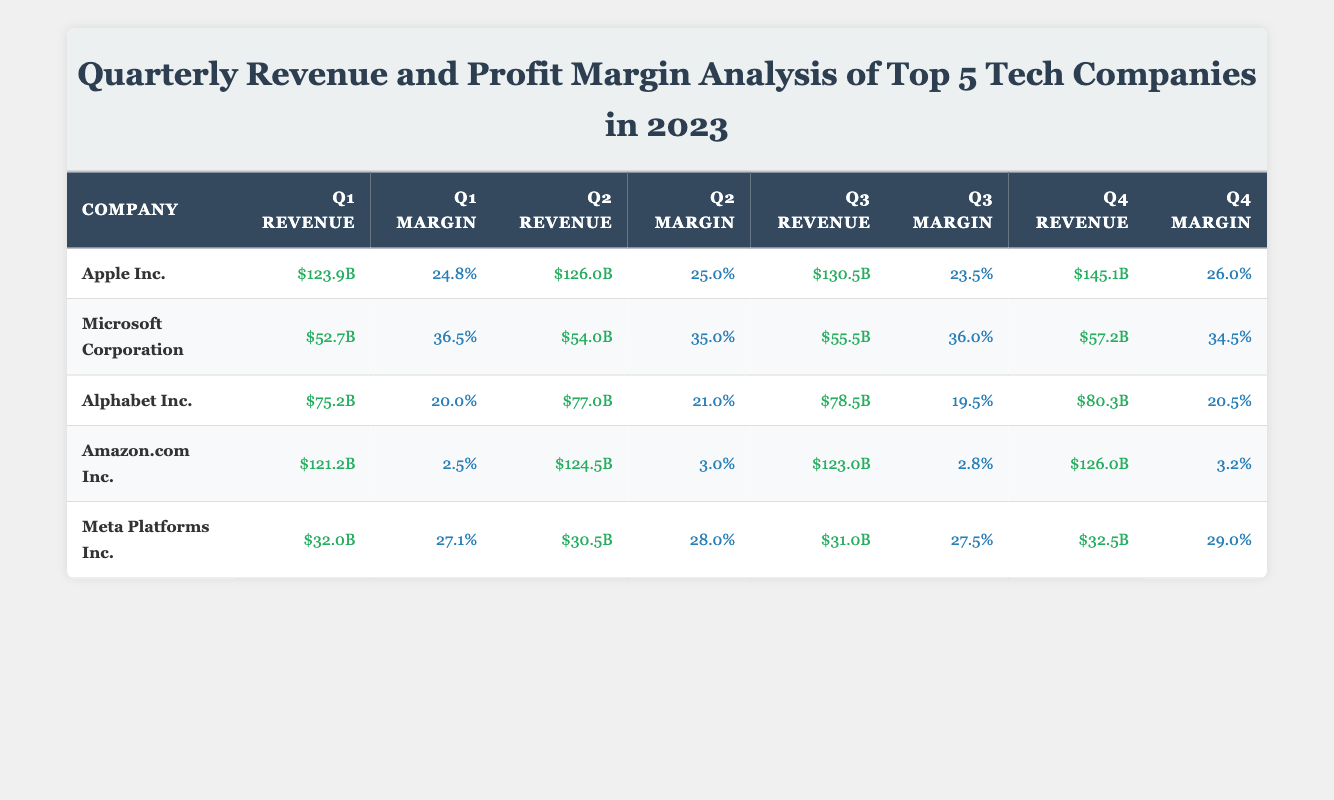What was Apple's revenue in Q2 2023? According to the table, Apple's revenue in Q2 is stated directly under the "Q2 Revenue" column for Apple Inc., which is $126.0 billion.
Answer: $126.0B Which company had the highest profit margin in Q1 2023? By looking at the "Q1 Margin" column, Microsoft Corporation displays the highest profit margin at 36.5%, as it is the largest value in that column compared to the other companies.
Answer: Microsoft Corporation What is the total revenue for Meta Platforms Inc. over all quarters? To find the total revenue, sum the revenues for Meta Platforms Inc. across the four quarters: ($32.0B + $30.5B + $31.0B + $32.5B) = $126.0B. Therefore, the total revenue is derived from adding all these figures together.
Answer: $126.0B Did Amazon.com Inc. see an increase in profit margin from Q1 to Q4? The profit margins for Amazon.com Inc. in Q1 is 2.5% and in Q4 is 3.2%. Since 3.2% is greater than 2.5%, Amazon did experience an increase in profit margin over this period.
Answer: Yes What is the average profit margin for Alphabet Inc. across the four quarters? The profit margins for Alphabet Inc. are 20.0%, 21.0%, 19.5%, and 20.5%. To find the average, add these margins (20.0 + 21.0 + 19.5 + 20.5 = 81.0) and divide by the number of quarters (4): 81.0 / 4 = 20.25%.
Answer: 20.25% What company maintained a profit margin of above 25% in every quarter? By examining the profit margin for each company across all quarters, Apple Inc. is the only company that had a profit margin above 25% in every quarter (24.8%, 25.0%, 23.5%, and 26.0%).
Answer: No Which company had the lowest revenue total across Q3? In Q3, examining the revenue figures: Apple Inc. ($130.5B), Microsoft Corporation ($55.5B), Alphabet Inc. ($78.5B), Amazon.com Inc. ($123.0B), and Meta Platforms Inc. ($31.0B), Meta Platforms Inc. has the lowest revenue at $31.0B.
Answer: Meta Platforms Inc What was the increase in revenue for Apple Inc. from Q1 to Q4? Apple's revenue in Q1 was $123.9B and in Q4 it was $145.1B. To calculate the increase, subtract Q1 revenue from Q4 revenue: $145.1B - $123.9B = $21.2B.
Answer: $21.2B 